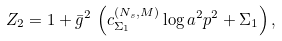<formula> <loc_0><loc_0><loc_500><loc_500>Z _ { 2 } = 1 + \bar { g } ^ { 2 } \, \left ( c _ { \Sigma _ { 1 } } ^ { ( N _ { s } , M ) } \log a ^ { 2 } p ^ { 2 } + \Sigma _ { 1 } \right ) ,</formula> 